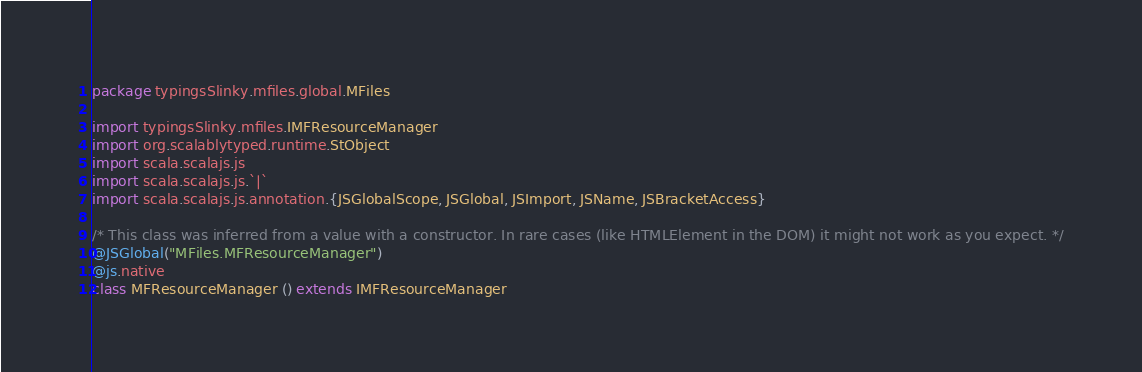Convert code to text. <code><loc_0><loc_0><loc_500><loc_500><_Scala_>package typingsSlinky.mfiles.global.MFiles

import typingsSlinky.mfiles.IMFResourceManager
import org.scalablytyped.runtime.StObject
import scala.scalajs.js
import scala.scalajs.js.`|`
import scala.scalajs.js.annotation.{JSGlobalScope, JSGlobal, JSImport, JSName, JSBracketAccess}

/* This class was inferred from a value with a constructor. In rare cases (like HTMLElement in the DOM) it might not work as you expect. */
@JSGlobal("MFiles.MFResourceManager")
@js.native
class MFResourceManager () extends IMFResourceManager
</code> 